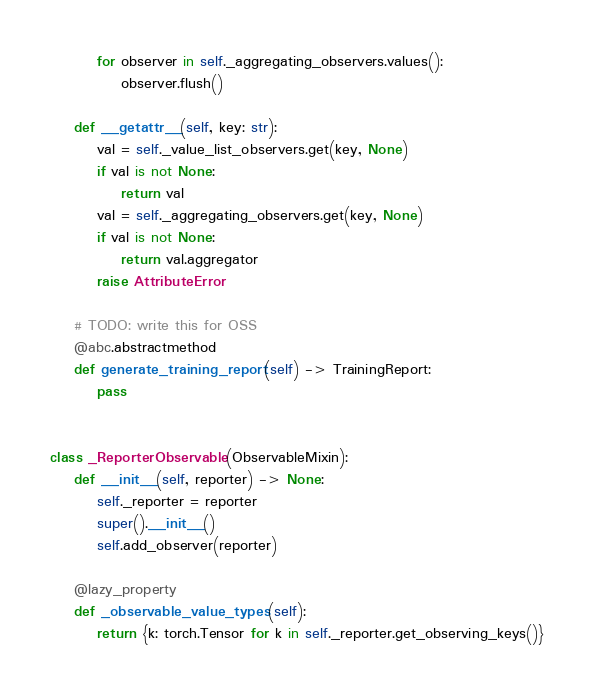<code> <loc_0><loc_0><loc_500><loc_500><_Python_>        for observer in self._aggregating_observers.values():
            observer.flush()

    def __getattr__(self, key: str):
        val = self._value_list_observers.get(key, None)
        if val is not None:
            return val
        val = self._aggregating_observers.get(key, None)
        if val is not None:
            return val.aggregator
        raise AttributeError

    # TODO: write this for OSS
    @abc.abstractmethod
    def generate_training_report(self) -> TrainingReport:
        pass


class _ReporterObservable(ObservableMixin):
    def __init__(self, reporter) -> None:
        self._reporter = reporter
        super().__init__()
        self.add_observer(reporter)

    @lazy_property
    def _observable_value_types(self):
        return {k: torch.Tensor for k in self._reporter.get_observing_keys()}
</code> 